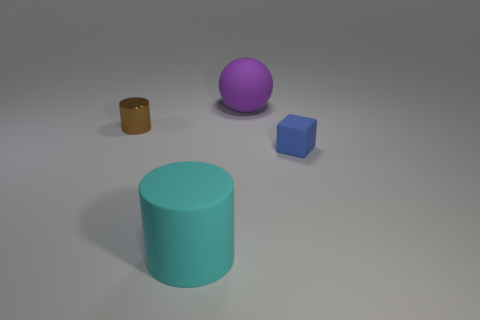Add 4 large purple rubber objects. How many objects exist? 8 Subtract all balls. How many objects are left? 3 Subtract 0 green spheres. How many objects are left? 4 Subtract all big gray rubber objects. Subtract all large cyan cylinders. How many objects are left? 3 Add 2 small blocks. How many small blocks are left? 3 Add 4 small green matte spheres. How many small green matte spheres exist? 4 